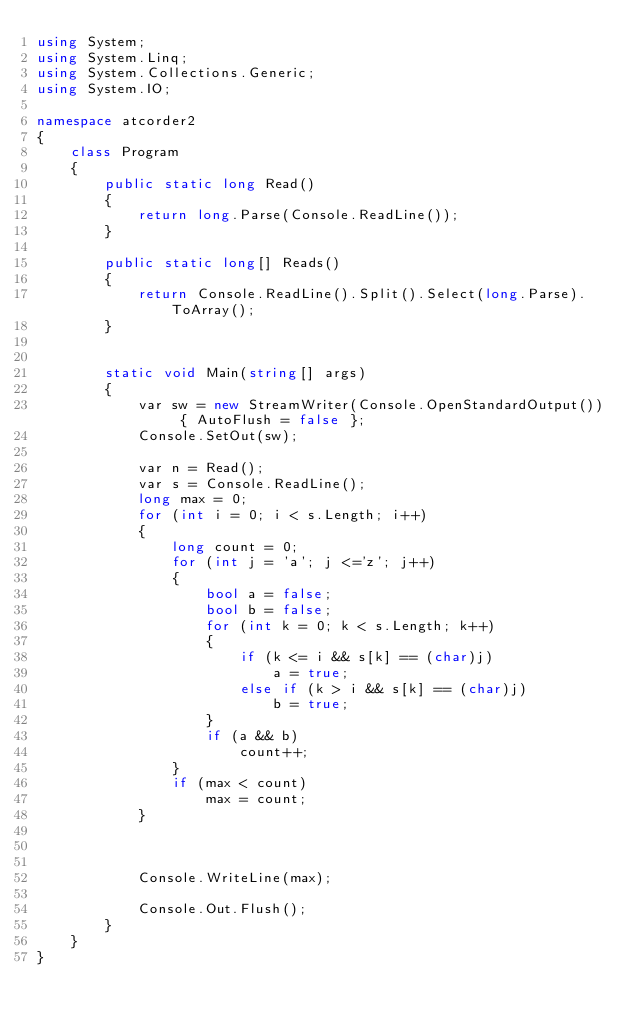Convert code to text. <code><loc_0><loc_0><loc_500><loc_500><_C#_>using System;
using System.Linq;
using System.Collections.Generic;
using System.IO;

namespace atcorder2
{
    class Program
    {
        public static long Read()
        {
            return long.Parse(Console.ReadLine());
        }

        public static long[] Reads()
        {
            return Console.ReadLine().Split().Select(long.Parse).ToArray();
        }


        static void Main(string[] args)
        {
            var sw = new StreamWriter(Console.OpenStandardOutput()) { AutoFlush = false };
            Console.SetOut(sw);

            var n = Read();
            var s = Console.ReadLine();
            long max = 0;
            for (int i = 0; i < s.Length; i++)
            {
                long count = 0;
                for (int j = 'a'; j <='z'; j++)
                {
                    bool a = false;
                    bool b = false;
                    for (int k = 0; k < s.Length; k++)
                    {
                        if (k <= i && s[k] == (char)j)
                            a = true;
                        else if (k > i && s[k] == (char)j)
                            b = true;
                    }
                    if (a && b)
                        count++;
                }
                if (max < count)
                    max = count;
            }



            Console.WriteLine(max);
           
            Console.Out.Flush();
        }
    }
}</code> 